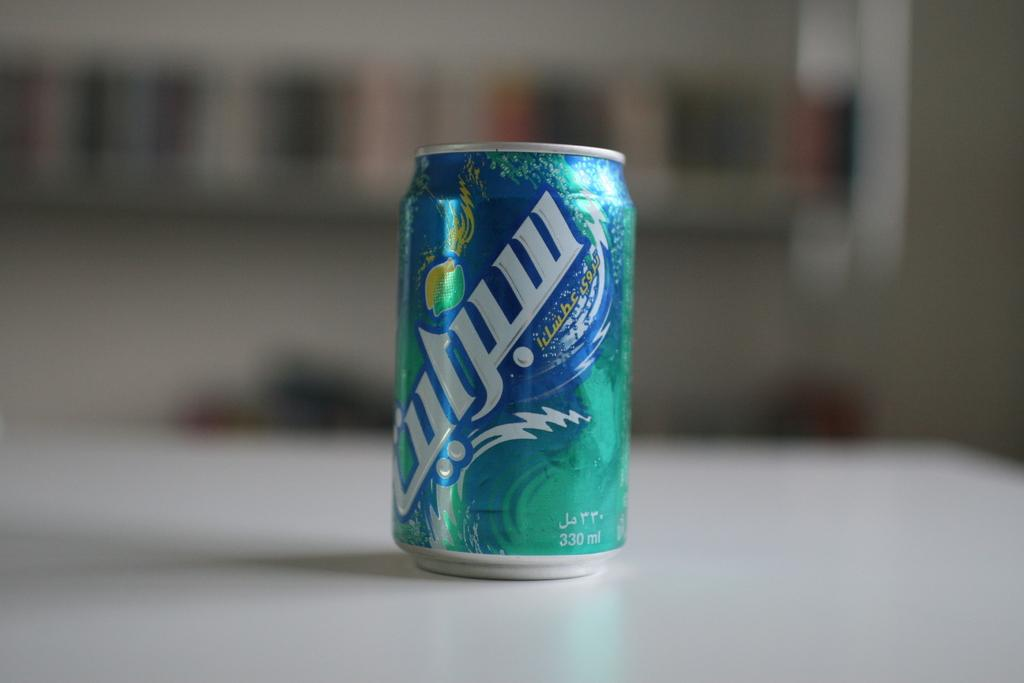What object is on the table in the image? There is a tin on the table in the image. What can be found on the surface of the tin? There is text on the tin. How would you describe the background of the image? The background of the image is blurry. Reasoning: Let'g: Let's think step by step in order to produce the conversation. We start by identifying the main object on the table, which is a tin. Then, we describe the specific feature of the tin, which is the text on its surface. Finally, we mention the background of the image, which is blurry. Each question is designed to elicit a specific detail about the image that is known from the provided facts. Absurd Question/Answer: What letter does the expert use to open the tin in the image? There is no expert present in the image, and the tin does not require a specific letter to be opened. 